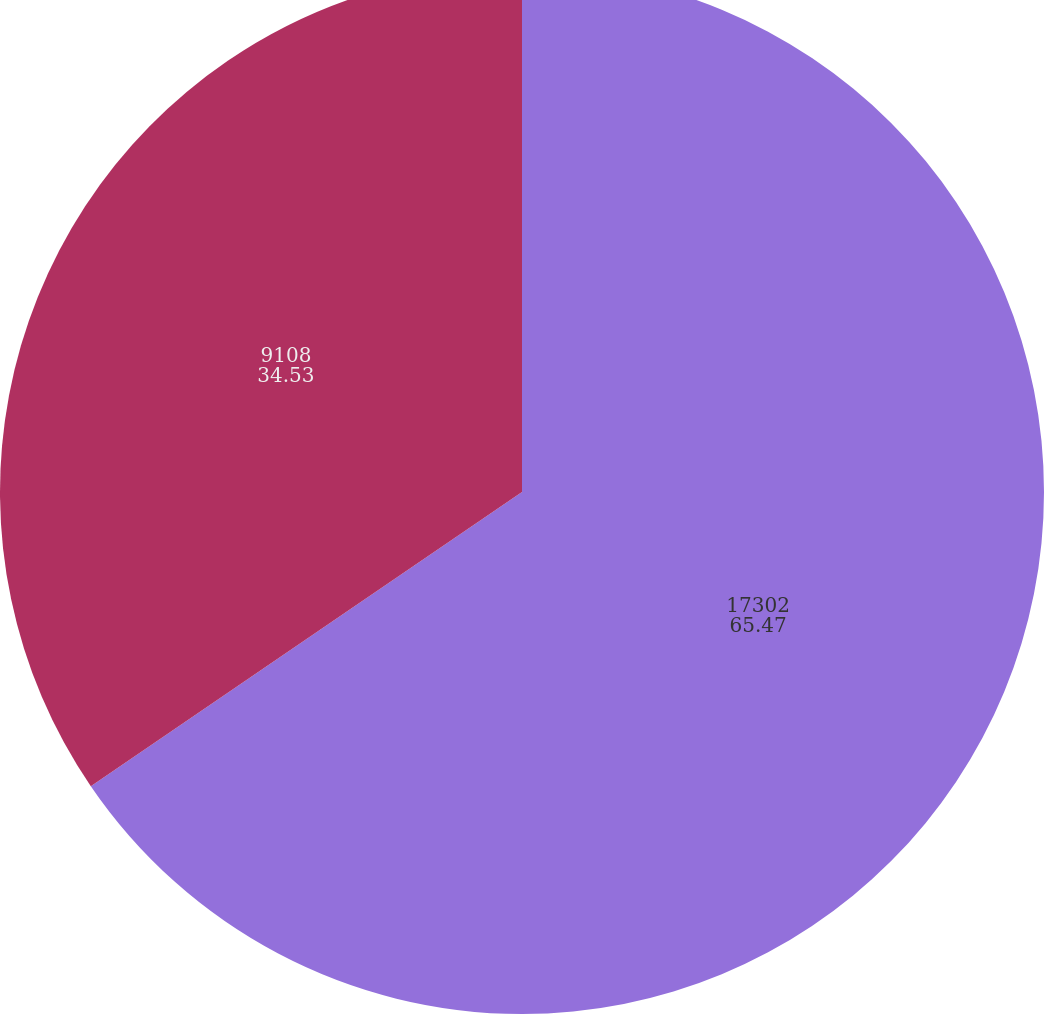<chart> <loc_0><loc_0><loc_500><loc_500><pie_chart><fcel>17302<fcel>9108<nl><fcel>65.47%<fcel>34.53%<nl></chart> 